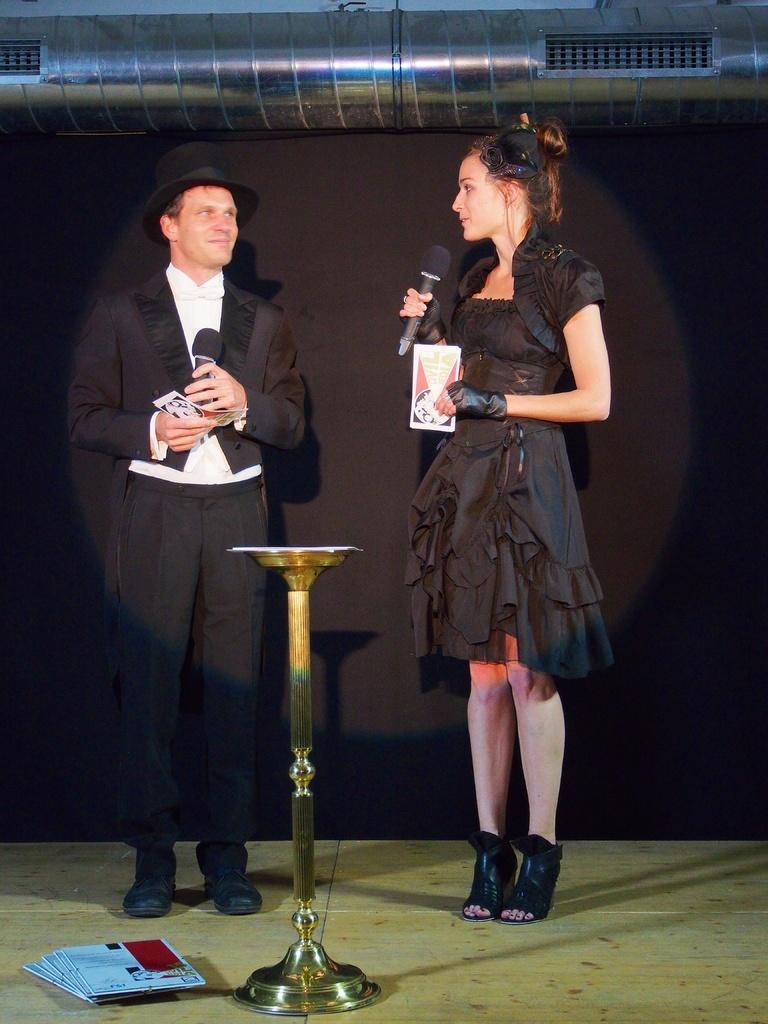Please provide a concise description of this image. This picture is of inside. In the center there is a woman wearing black color dress, holding a microphone and standing and there is a man wearing black color suit, holding a microphone and a paper, smiling and standing. In the foreground we can see a stand placed on the ground and some books placed on the ground. On the top we can see a duct of an air conditioner and in the background we can see a curtain which is in black color. 